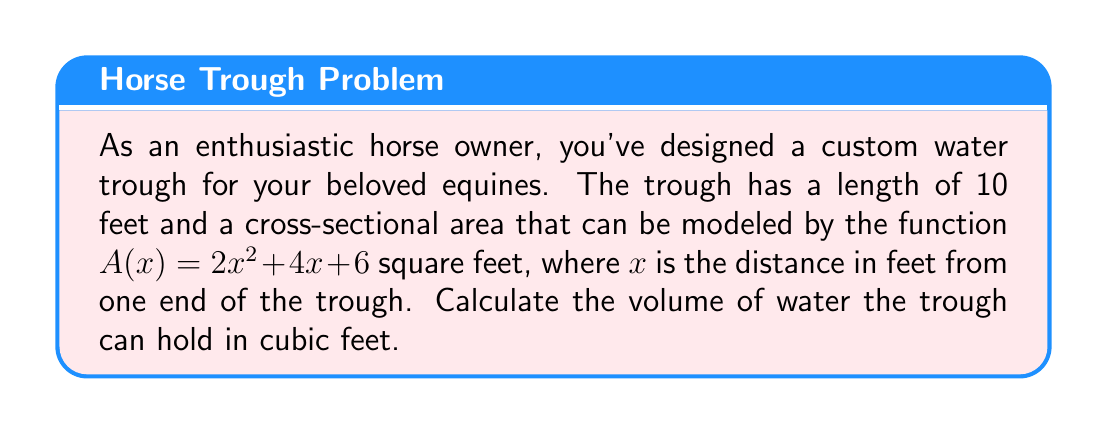Solve this math problem. To find the volume of the custom-shaped water trough, we need to use integration. The volume of a solid with a variable cross-sectional area can be calculated using the formula:

$$V = \int_a^b A(x) dx$$

Where $A(x)$ is the cross-sectional area function, and $a$ and $b$ are the limits of integration.

Given:
- Length of the trough: 10 feet
- Cross-sectional area function: $A(x) = 2x^2 + 4x + 6$ sq ft
- Limits of integration: $a = 0$, $b = 10$

Steps:
1) Set up the integral:
   $$V = \int_0^{10} (2x^2 + 4x + 6) dx$$

2) Integrate the function:
   $$V = \left[\frac{2x^3}{3} + 2x^2 + 6x\right]_0^{10}$$

3) Evaluate the integral at the limits:
   $$V = \left(\frac{2(10^3)}{3} + 2(10^2) + 6(10)\right) - \left(\frac{2(0^3)}{3} + 2(0^2) + 6(0)\right)$$

4) Simplify:
   $$V = \left(\frac{2000}{3} + 200 + 60\right) - 0$$
   $$V = \frac{2000}{3} + 260$$
   $$V = \frac{2000 + 780}{3}$$
   $$V = \frac{2780}{3}$$

5) Calculate the final result:
   $$V \approx 926.67 \text{ cubic feet}$$
Answer: $\frac{2780}{3} \approx 926.67 \text{ cubic feet}$ 